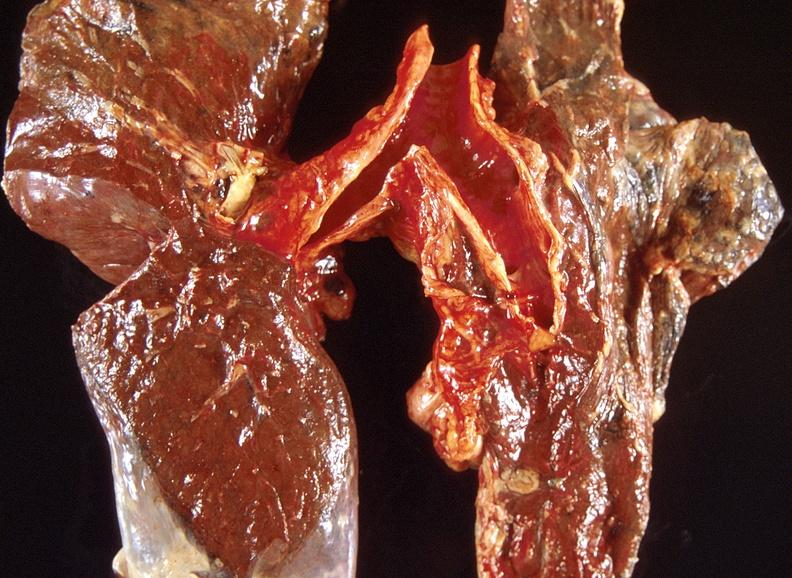s fetus developing very early present?
Answer the question using a single word or phrase. No 